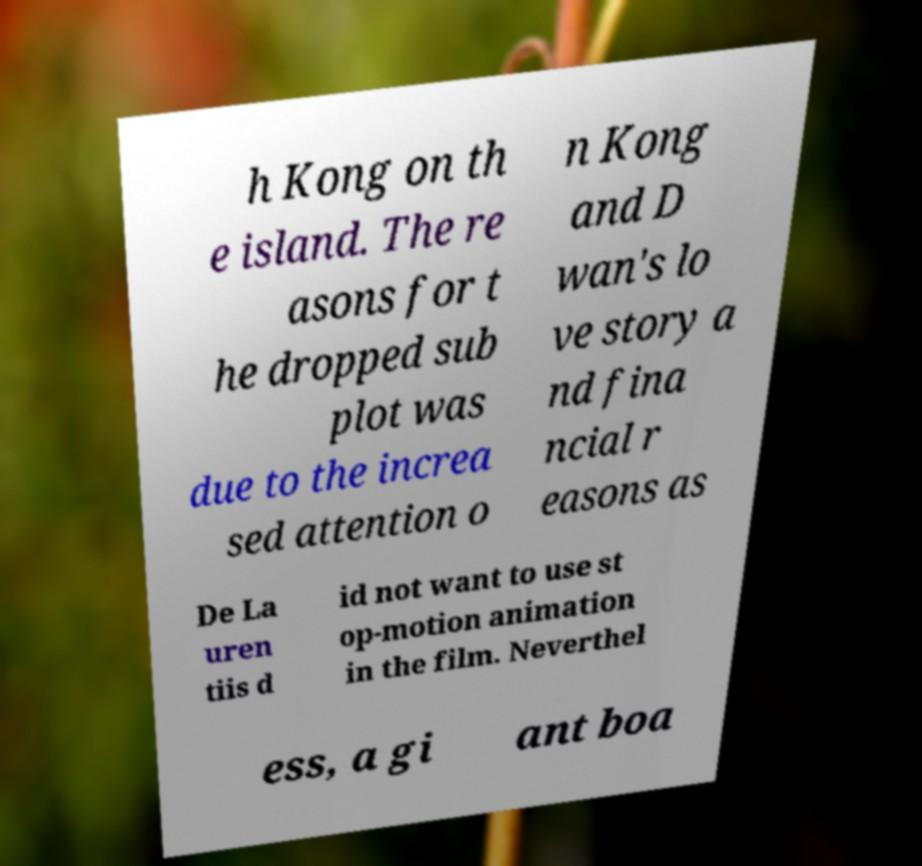What messages or text are displayed in this image? I need them in a readable, typed format. h Kong on th e island. The re asons for t he dropped sub plot was due to the increa sed attention o n Kong and D wan's lo ve story a nd fina ncial r easons as De La uren tiis d id not want to use st op-motion animation in the film. Neverthel ess, a gi ant boa 